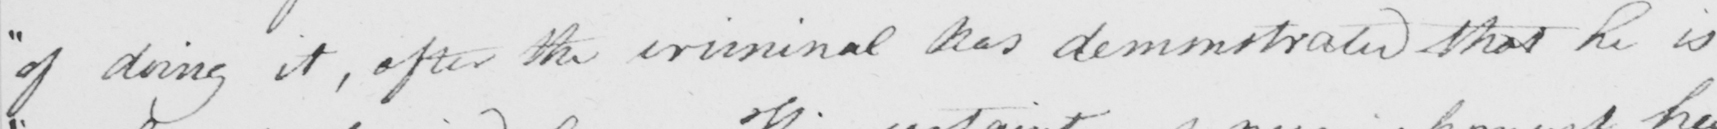Please transcribe the handwritten text in this image. " of doing it , after the criminal has demonstrated that he is 